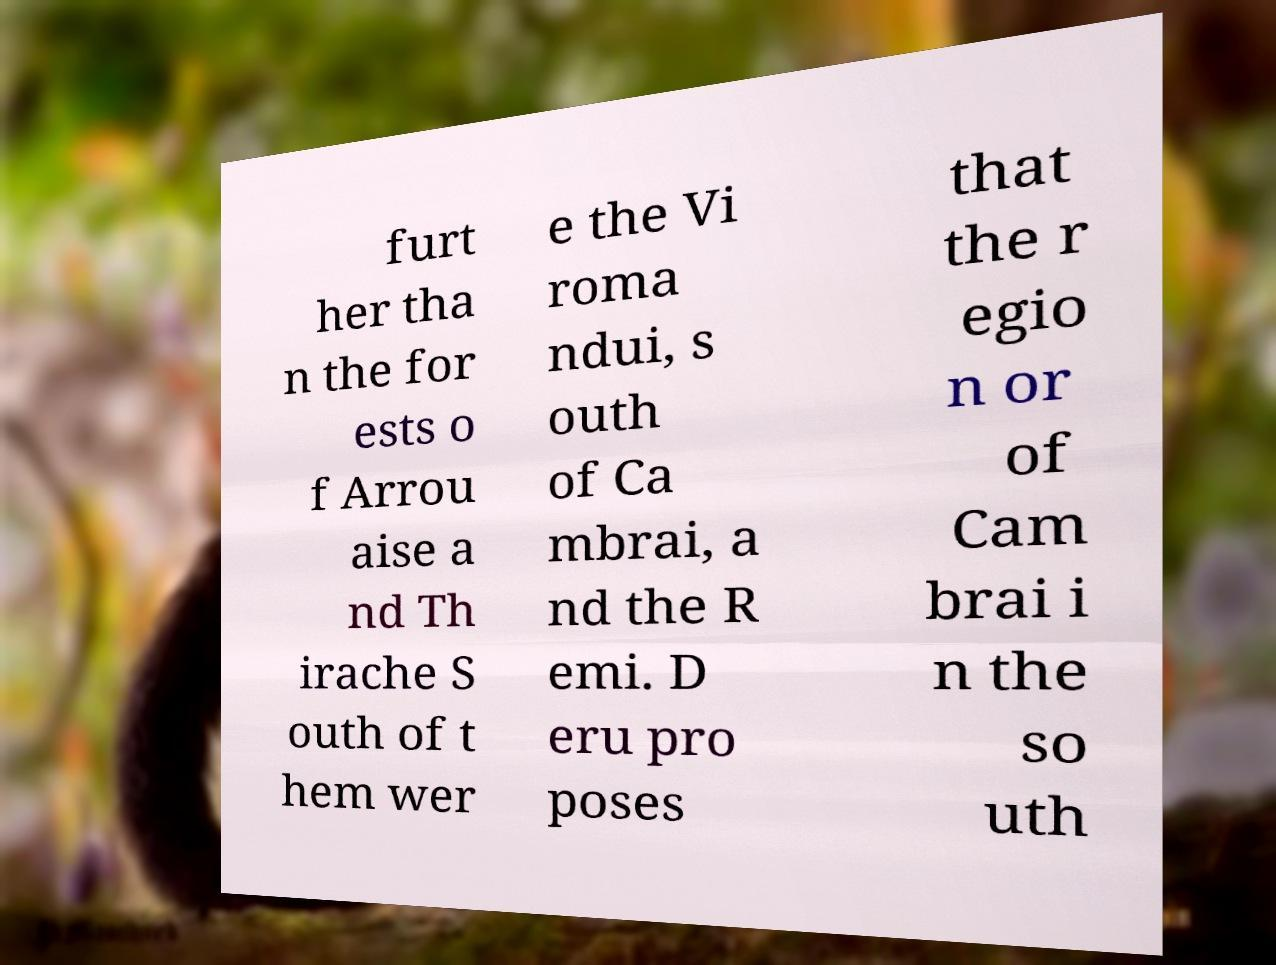What messages or text are displayed in this image? I need them in a readable, typed format. furt her tha n the for ests o f Arrou aise a nd Th irache S outh of t hem wer e the Vi roma ndui, s outh of Ca mbrai, a nd the R emi. D eru pro poses that the r egio n or of Cam brai i n the so uth 